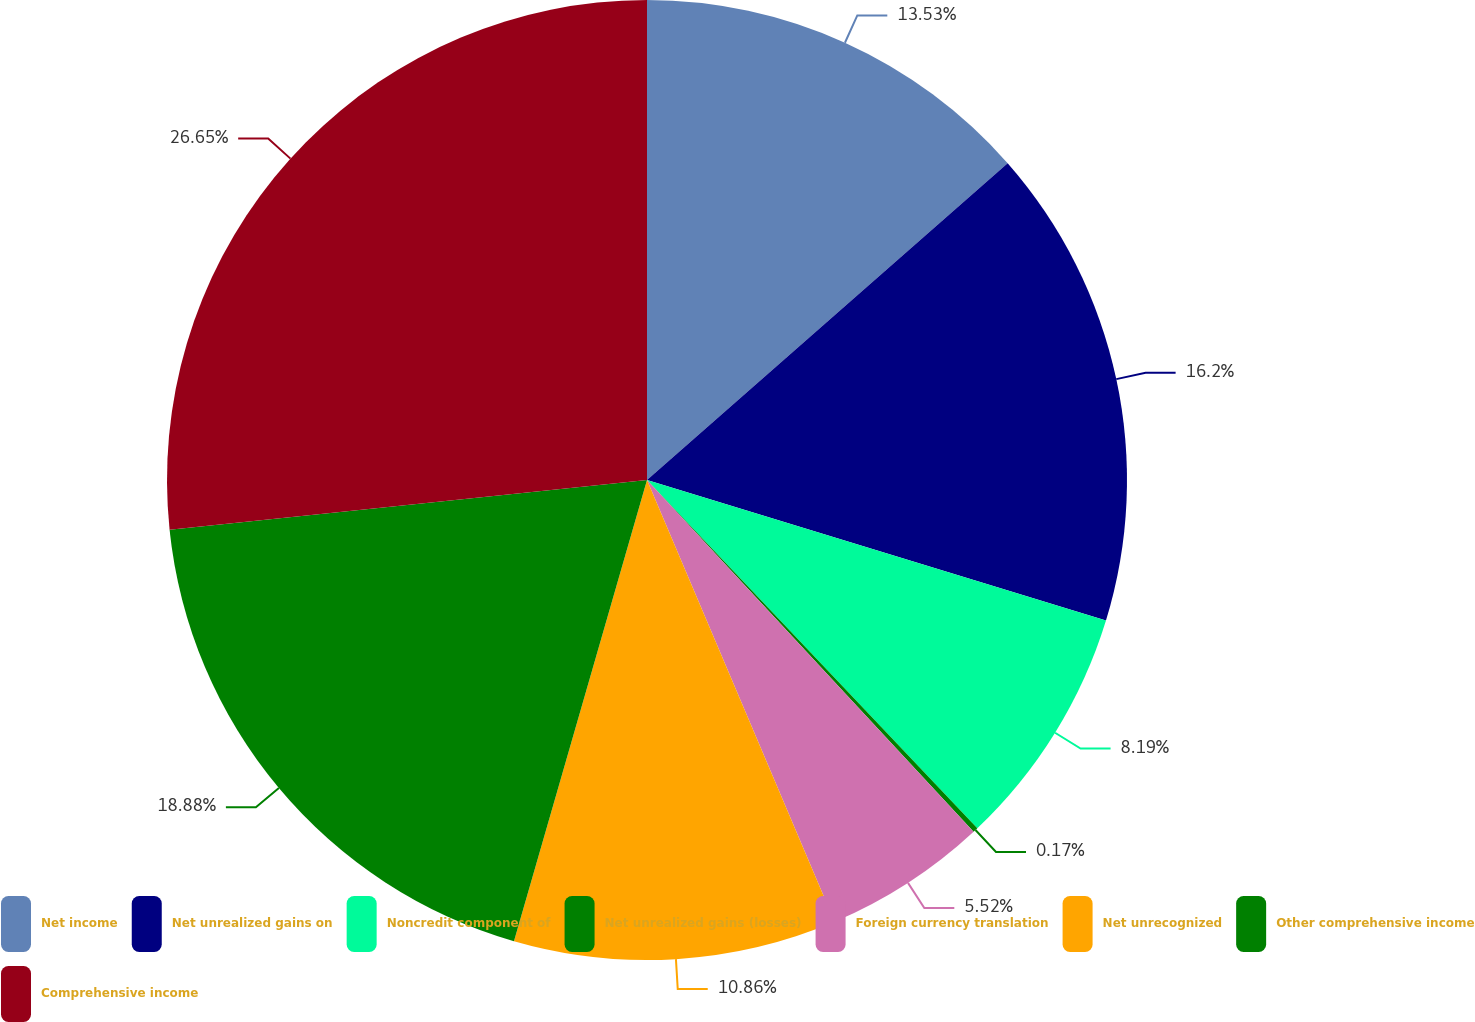<chart> <loc_0><loc_0><loc_500><loc_500><pie_chart><fcel>Net income<fcel>Net unrealized gains on<fcel>Noncredit component of<fcel>Net unrealized gains (losses)<fcel>Foreign currency translation<fcel>Net unrecognized<fcel>Other comprehensive income<fcel>Comprehensive income<nl><fcel>13.53%<fcel>16.2%<fcel>8.19%<fcel>0.17%<fcel>5.52%<fcel>10.86%<fcel>18.88%<fcel>26.65%<nl></chart> 